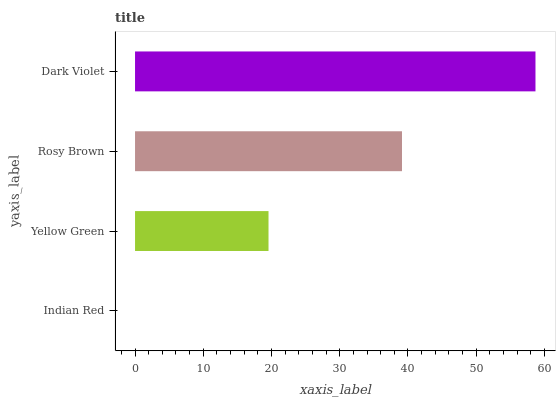Is Indian Red the minimum?
Answer yes or no. Yes. Is Dark Violet the maximum?
Answer yes or no. Yes. Is Yellow Green the minimum?
Answer yes or no. No. Is Yellow Green the maximum?
Answer yes or no. No. Is Yellow Green greater than Indian Red?
Answer yes or no. Yes. Is Indian Red less than Yellow Green?
Answer yes or no. Yes. Is Indian Red greater than Yellow Green?
Answer yes or no. No. Is Yellow Green less than Indian Red?
Answer yes or no. No. Is Rosy Brown the high median?
Answer yes or no. Yes. Is Yellow Green the low median?
Answer yes or no. Yes. Is Indian Red the high median?
Answer yes or no. No. Is Rosy Brown the low median?
Answer yes or no. No. 